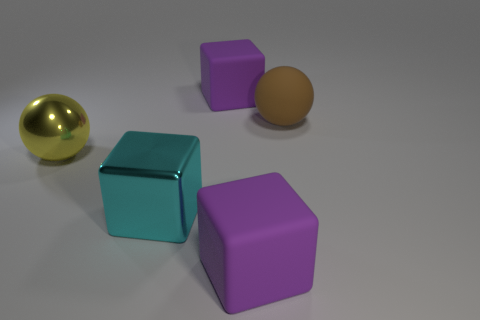Add 5 gray metal objects. How many objects exist? 10 Subtract all cubes. How many objects are left? 2 Subtract all cyan shiny blocks. Subtract all big rubber objects. How many objects are left? 1 Add 5 large cyan shiny objects. How many large cyan shiny objects are left? 6 Add 4 red rubber objects. How many red rubber objects exist? 4 Subtract 0 blue cylinders. How many objects are left? 5 